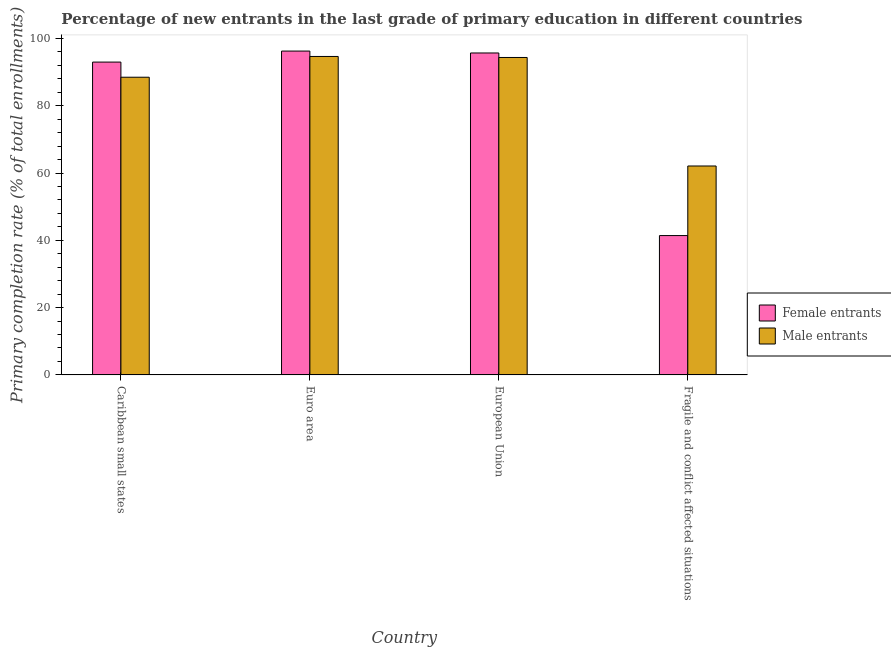How many different coloured bars are there?
Provide a short and direct response. 2. How many groups of bars are there?
Offer a very short reply. 4. Are the number of bars per tick equal to the number of legend labels?
Offer a very short reply. Yes. How many bars are there on the 1st tick from the left?
Keep it short and to the point. 2. How many bars are there on the 3rd tick from the right?
Your response must be concise. 2. In how many cases, is the number of bars for a given country not equal to the number of legend labels?
Keep it short and to the point. 0. What is the primary completion rate of female entrants in Euro area?
Provide a short and direct response. 96.24. Across all countries, what is the maximum primary completion rate of female entrants?
Offer a very short reply. 96.24. Across all countries, what is the minimum primary completion rate of male entrants?
Offer a terse response. 62.08. In which country was the primary completion rate of female entrants maximum?
Keep it short and to the point. Euro area. In which country was the primary completion rate of female entrants minimum?
Provide a short and direct response. Fragile and conflict affected situations. What is the total primary completion rate of female entrants in the graph?
Your answer should be very brief. 326.27. What is the difference between the primary completion rate of male entrants in Euro area and that in European Union?
Give a very brief answer. 0.3. What is the difference between the primary completion rate of male entrants in Euro area and the primary completion rate of female entrants in Caribbean small states?
Provide a short and direct response. 1.67. What is the average primary completion rate of male entrants per country?
Your answer should be compact. 84.88. What is the difference between the primary completion rate of female entrants and primary completion rate of male entrants in European Union?
Make the answer very short. 1.34. In how many countries, is the primary completion rate of male entrants greater than 28 %?
Ensure brevity in your answer.  4. What is the ratio of the primary completion rate of male entrants in European Union to that in Fragile and conflict affected situations?
Keep it short and to the point. 1.52. Is the primary completion rate of female entrants in Euro area less than that in European Union?
Give a very brief answer. No. What is the difference between the highest and the second highest primary completion rate of female entrants?
Provide a succinct answer. 0.57. What is the difference between the highest and the lowest primary completion rate of female entrants?
Make the answer very short. 54.83. What does the 1st bar from the left in Fragile and conflict affected situations represents?
Provide a short and direct response. Female entrants. What does the 1st bar from the right in Caribbean small states represents?
Provide a succinct answer. Male entrants. How many bars are there?
Ensure brevity in your answer.  8. How many legend labels are there?
Provide a succinct answer. 2. How are the legend labels stacked?
Make the answer very short. Vertical. What is the title of the graph?
Your answer should be very brief. Percentage of new entrants in the last grade of primary education in different countries. What is the label or title of the Y-axis?
Your response must be concise. Primary completion rate (% of total enrollments). What is the Primary completion rate (% of total enrollments) in Female entrants in Caribbean small states?
Make the answer very short. 92.96. What is the Primary completion rate (% of total enrollments) in Male entrants in Caribbean small states?
Provide a succinct answer. 88.46. What is the Primary completion rate (% of total enrollments) in Female entrants in Euro area?
Make the answer very short. 96.24. What is the Primary completion rate (% of total enrollments) of Male entrants in Euro area?
Give a very brief answer. 94.63. What is the Primary completion rate (% of total enrollments) in Female entrants in European Union?
Provide a short and direct response. 95.67. What is the Primary completion rate (% of total enrollments) of Male entrants in European Union?
Ensure brevity in your answer.  94.33. What is the Primary completion rate (% of total enrollments) in Female entrants in Fragile and conflict affected situations?
Your answer should be very brief. 41.41. What is the Primary completion rate (% of total enrollments) in Male entrants in Fragile and conflict affected situations?
Provide a succinct answer. 62.08. Across all countries, what is the maximum Primary completion rate (% of total enrollments) of Female entrants?
Your answer should be compact. 96.24. Across all countries, what is the maximum Primary completion rate (% of total enrollments) of Male entrants?
Provide a succinct answer. 94.63. Across all countries, what is the minimum Primary completion rate (% of total enrollments) of Female entrants?
Provide a succinct answer. 41.41. Across all countries, what is the minimum Primary completion rate (% of total enrollments) of Male entrants?
Offer a very short reply. 62.08. What is the total Primary completion rate (% of total enrollments) of Female entrants in the graph?
Your answer should be compact. 326.27. What is the total Primary completion rate (% of total enrollments) of Male entrants in the graph?
Your answer should be compact. 339.51. What is the difference between the Primary completion rate (% of total enrollments) in Female entrants in Caribbean small states and that in Euro area?
Give a very brief answer. -3.27. What is the difference between the Primary completion rate (% of total enrollments) of Male entrants in Caribbean small states and that in Euro area?
Your response must be concise. -6.17. What is the difference between the Primary completion rate (% of total enrollments) of Female entrants in Caribbean small states and that in European Union?
Provide a short and direct response. -2.71. What is the difference between the Primary completion rate (% of total enrollments) in Male entrants in Caribbean small states and that in European Union?
Make the answer very short. -5.87. What is the difference between the Primary completion rate (% of total enrollments) in Female entrants in Caribbean small states and that in Fragile and conflict affected situations?
Your answer should be very brief. 51.56. What is the difference between the Primary completion rate (% of total enrollments) in Male entrants in Caribbean small states and that in Fragile and conflict affected situations?
Offer a very short reply. 26.38. What is the difference between the Primary completion rate (% of total enrollments) in Female entrants in Euro area and that in European Union?
Ensure brevity in your answer.  0.57. What is the difference between the Primary completion rate (% of total enrollments) of Male entrants in Euro area and that in European Union?
Offer a terse response. 0.3. What is the difference between the Primary completion rate (% of total enrollments) in Female entrants in Euro area and that in Fragile and conflict affected situations?
Offer a very short reply. 54.83. What is the difference between the Primary completion rate (% of total enrollments) in Male entrants in Euro area and that in Fragile and conflict affected situations?
Make the answer very short. 32.55. What is the difference between the Primary completion rate (% of total enrollments) of Female entrants in European Union and that in Fragile and conflict affected situations?
Your answer should be very brief. 54.26. What is the difference between the Primary completion rate (% of total enrollments) of Male entrants in European Union and that in Fragile and conflict affected situations?
Provide a succinct answer. 32.25. What is the difference between the Primary completion rate (% of total enrollments) in Female entrants in Caribbean small states and the Primary completion rate (% of total enrollments) in Male entrants in Euro area?
Provide a short and direct response. -1.67. What is the difference between the Primary completion rate (% of total enrollments) in Female entrants in Caribbean small states and the Primary completion rate (% of total enrollments) in Male entrants in European Union?
Your response must be concise. -1.37. What is the difference between the Primary completion rate (% of total enrollments) of Female entrants in Caribbean small states and the Primary completion rate (% of total enrollments) of Male entrants in Fragile and conflict affected situations?
Provide a short and direct response. 30.88. What is the difference between the Primary completion rate (% of total enrollments) in Female entrants in Euro area and the Primary completion rate (% of total enrollments) in Male entrants in European Union?
Your answer should be compact. 1.91. What is the difference between the Primary completion rate (% of total enrollments) of Female entrants in Euro area and the Primary completion rate (% of total enrollments) of Male entrants in Fragile and conflict affected situations?
Provide a succinct answer. 34.15. What is the difference between the Primary completion rate (% of total enrollments) in Female entrants in European Union and the Primary completion rate (% of total enrollments) in Male entrants in Fragile and conflict affected situations?
Offer a terse response. 33.59. What is the average Primary completion rate (% of total enrollments) of Female entrants per country?
Your answer should be compact. 81.57. What is the average Primary completion rate (% of total enrollments) of Male entrants per country?
Make the answer very short. 84.88. What is the difference between the Primary completion rate (% of total enrollments) of Female entrants and Primary completion rate (% of total enrollments) of Male entrants in Caribbean small states?
Ensure brevity in your answer.  4.5. What is the difference between the Primary completion rate (% of total enrollments) in Female entrants and Primary completion rate (% of total enrollments) in Male entrants in Euro area?
Offer a terse response. 1.6. What is the difference between the Primary completion rate (% of total enrollments) in Female entrants and Primary completion rate (% of total enrollments) in Male entrants in European Union?
Your answer should be compact. 1.34. What is the difference between the Primary completion rate (% of total enrollments) in Female entrants and Primary completion rate (% of total enrollments) in Male entrants in Fragile and conflict affected situations?
Provide a short and direct response. -20.68. What is the ratio of the Primary completion rate (% of total enrollments) of Male entrants in Caribbean small states to that in Euro area?
Keep it short and to the point. 0.93. What is the ratio of the Primary completion rate (% of total enrollments) in Female entrants in Caribbean small states to that in European Union?
Your response must be concise. 0.97. What is the ratio of the Primary completion rate (% of total enrollments) in Male entrants in Caribbean small states to that in European Union?
Offer a terse response. 0.94. What is the ratio of the Primary completion rate (% of total enrollments) of Female entrants in Caribbean small states to that in Fragile and conflict affected situations?
Provide a short and direct response. 2.25. What is the ratio of the Primary completion rate (% of total enrollments) of Male entrants in Caribbean small states to that in Fragile and conflict affected situations?
Your answer should be compact. 1.42. What is the ratio of the Primary completion rate (% of total enrollments) in Female entrants in Euro area to that in European Union?
Provide a succinct answer. 1.01. What is the ratio of the Primary completion rate (% of total enrollments) in Male entrants in Euro area to that in European Union?
Keep it short and to the point. 1. What is the ratio of the Primary completion rate (% of total enrollments) of Female entrants in Euro area to that in Fragile and conflict affected situations?
Provide a short and direct response. 2.32. What is the ratio of the Primary completion rate (% of total enrollments) in Male entrants in Euro area to that in Fragile and conflict affected situations?
Your answer should be very brief. 1.52. What is the ratio of the Primary completion rate (% of total enrollments) in Female entrants in European Union to that in Fragile and conflict affected situations?
Offer a terse response. 2.31. What is the ratio of the Primary completion rate (% of total enrollments) of Male entrants in European Union to that in Fragile and conflict affected situations?
Keep it short and to the point. 1.52. What is the difference between the highest and the second highest Primary completion rate (% of total enrollments) of Female entrants?
Provide a short and direct response. 0.57. What is the difference between the highest and the second highest Primary completion rate (% of total enrollments) of Male entrants?
Your answer should be compact. 0.3. What is the difference between the highest and the lowest Primary completion rate (% of total enrollments) in Female entrants?
Give a very brief answer. 54.83. What is the difference between the highest and the lowest Primary completion rate (% of total enrollments) in Male entrants?
Offer a very short reply. 32.55. 